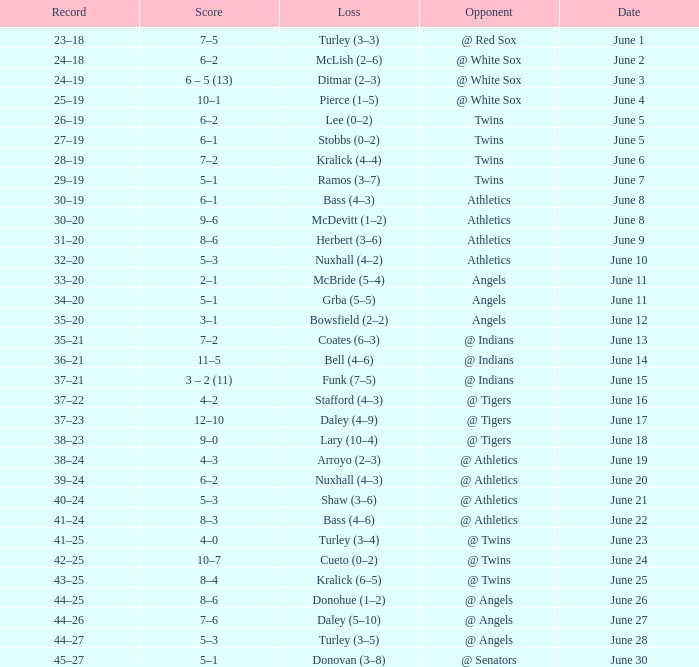What was the score from the game played on June 22? 8–3. 